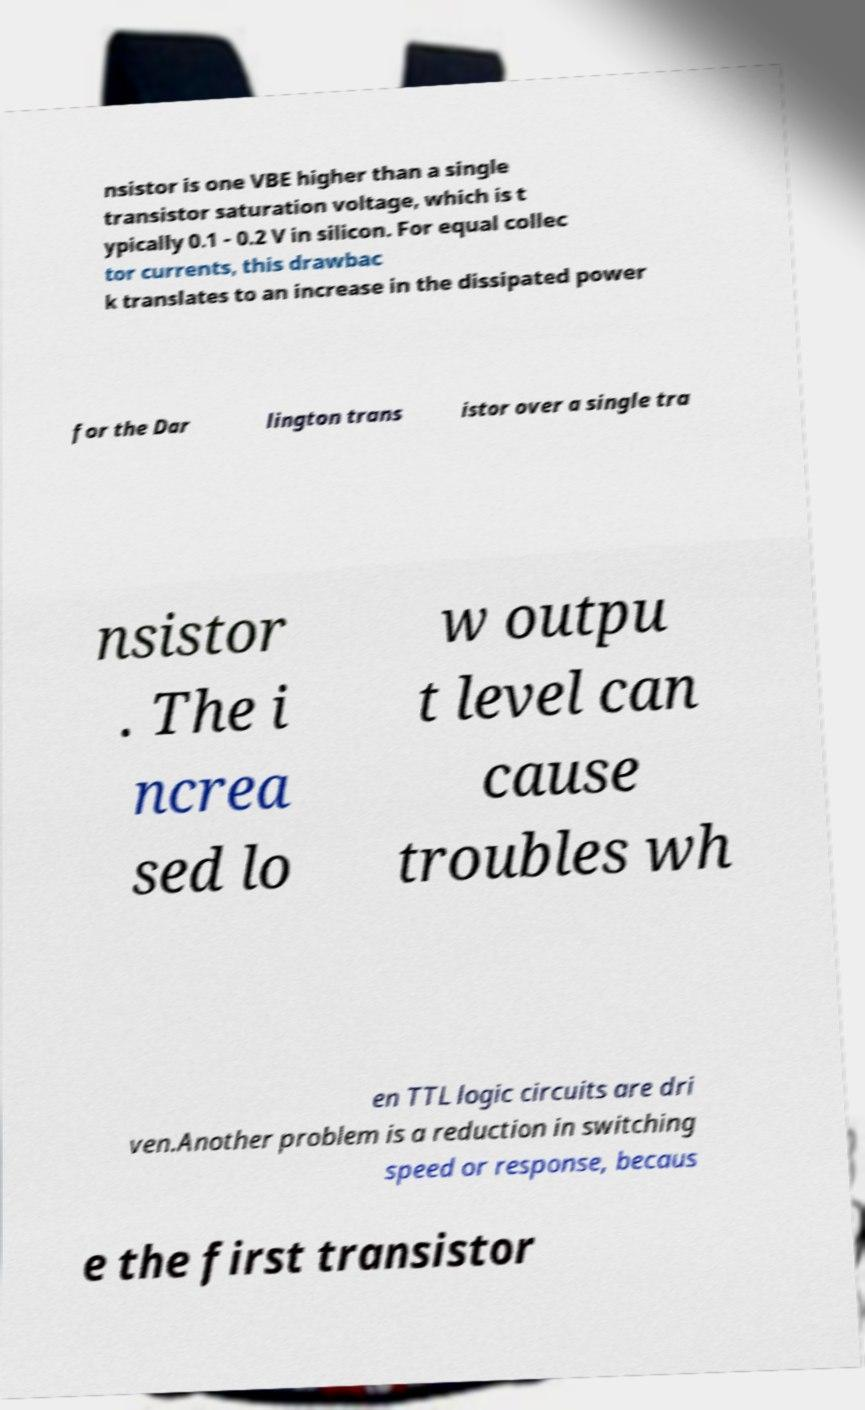What messages or text are displayed in this image? I need them in a readable, typed format. nsistor is one VBE higher than a single transistor saturation voltage, which is t ypically 0.1 - 0.2 V in silicon. For equal collec tor currents, this drawbac k translates to an increase in the dissipated power for the Dar lington trans istor over a single tra nsistor . The i ncrea sed lo w outpu t level can cause troubles wh en TTL logic circuits are dri ven.Another problem is a reduction in switching speed or response, becaus e the first transistor 